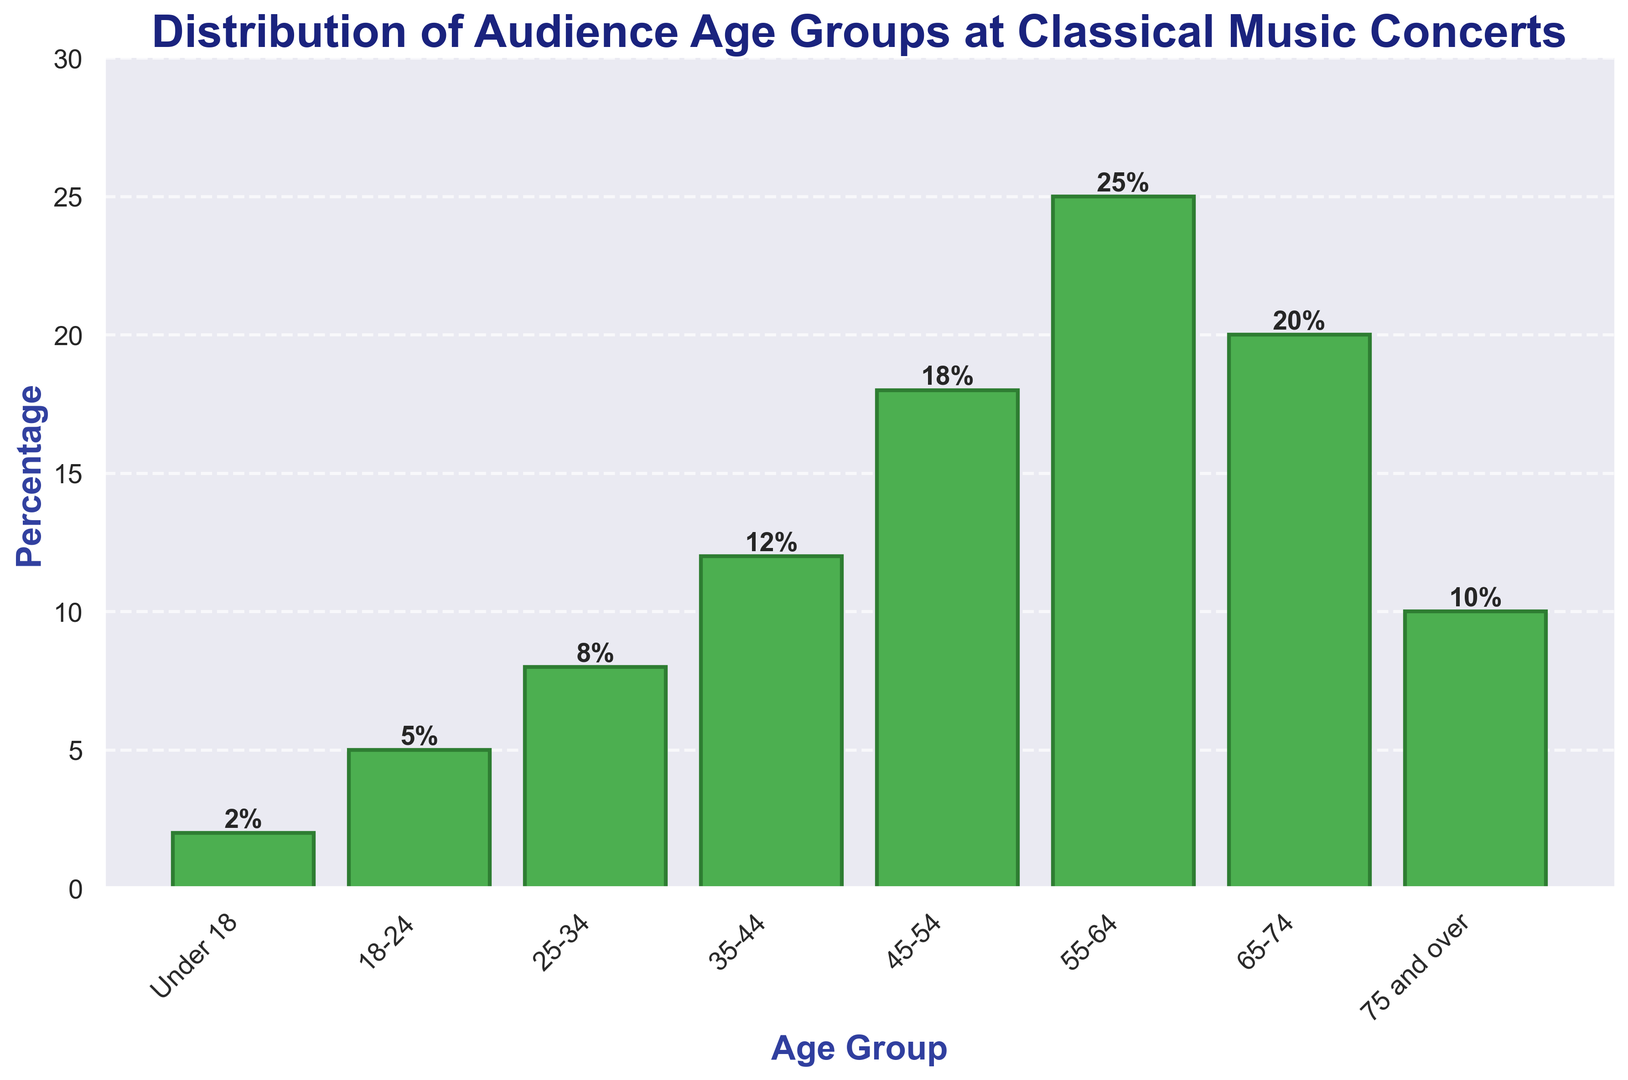What is the age group with the highest percentage of the audience? The height of the bars represents the percentage of the audience in each age group. The tallest bar corresponds to the age group with the highest percentage. From the figure, the age group 55-64 has the highest bar at 25%.
Answer: 55-64 Which age groups have a higher percentage than the 18-24 age group? The 18-24 age group has a percentage of 5%. By looking at the heights of the bars higher than the 18-24 bar, we see that the age groups 25-34, 35-44, 45-54, 55-64, and 65-74 have higher percentages.
Answer: 25-34, 35-44, 45-54, 55-64, 65-74 What is the total percentage of all age groups under 45? The age groups under 45 are Under 18, 18-24, 25-34, and 35-44. Their percentages are 2%, 5%, 8%, and 12% respectively. Adding these together: 2% + 5% + 8% + 12% = 27%.
Answer: 27% How much more popular is the 55-64 age group compared to the 18-24 age group? The 55-64 age group has a percentage of 25%, and the 18-24 age group has a percentage of 5%. To find the difference: 25% - 5% = 20%.
Answer: 20% What percentage of the audience is 65 or older? The relevant age groups are 65-74 and 75 and over, with percentages of 20% and 10%, respectively. Adding these together: 20% + 10% = 30%.
Answer: 30% Which age group has the lowest representation in the audience? The bar corresponding to the Under 18 age group is the shortest, indicating it has the lowest percentage of 2%.
Answer: Under 18 Compare the combined percentage of the age groups 45-54 and 55-64 with the age group 65-74. Which is greater and by how much? The combined percentage of the age groups 45-54 and 55-64 is 18% + 25% = 43%. The percentage of the 65-74 age group is 20%. The difference is: 43% - 20% = 23%.
Answer: 45-54 and 55-64 by 23% What is the average percentage of the audience for the age groups 45-54, 55-64, and 65-74? The percentages for the age groups 45-54, 55-64, and 65-74 are 18%, 25%, and 20% respectively. Calculate the average by summing them and dividing by 3: (18% + 25% + 20%) / 3 = 21%.
Answer: 21% What is the difference in percentage between the two oldest and two youngest age groups? The two oldest age groups are 65-74 and 75 and over with percentages of 20% and 10%. The two youngest age groups are Under 18 and 18-24 with percentages of 2% and 5%. Summing the oldest: 20% + 10% = 30%. Summing the youngest: 2% + 5% = 7%. The difference is: 30% - 7% = 23%.
Answer: 23% Which age group has a percentage that is exactly half of the 55-64 age group? The 55-64 age group has a percentage of 25%, and half of that is 12.5%. Among the age groups, none matches 12.5% exactly, but the 35-44 age group has 12%, which is approximately half of 25%.
Answer: 35-44 